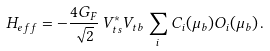<formula> <loc_0><loc_0><loc_500><loc_500>H _ { e f f } = - \frac { 4 G _ { F } } { \sqrt { 2 } } \, V _ { t s } ^ { * } V _ { t b } \sum _ { i } C _ { i } ( \mu _ { b } ) O _ { i } ( \mu _ { b } ) \, .</formula> 